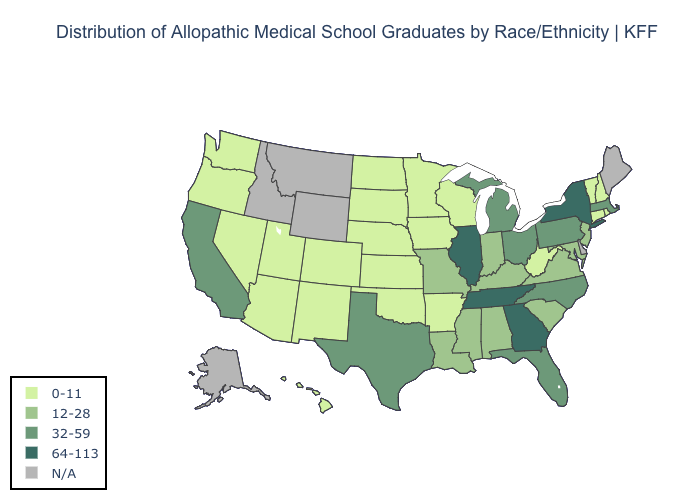Which states have the lowest value in the South?
Give a very brief answer. Arkansas, Oklahoma, West Virginia. What is the value of Montana?
Write a very short answer. N/A. Does the map have missing data?
Answer briefly. Yes. Does Arizona have the highest value in the West?
Keep it brief. No. Does North Carolina have the highest value in the USA?
Write a very short answer. No. Does Georgia have the highest value in the USA?
Keep it brief. Yes. Is the legend a continuous bar?
Quick response, please. No. Does the map have missing data?
Keep it brief. Yes. Does the map have missing data?
Write a very short answer. Yes. What is the value of Colorado?
Keep it brief. 0-11. Name the states that have a value in the range N/A?
Quick response, please. Alaska, Delaware, Idaho, Maine, Montana, Wyoming. What is the value of Massachusetts?
Concise answer only. 32-59. What is the value of Maryland?
Short answer required. 12-28. 